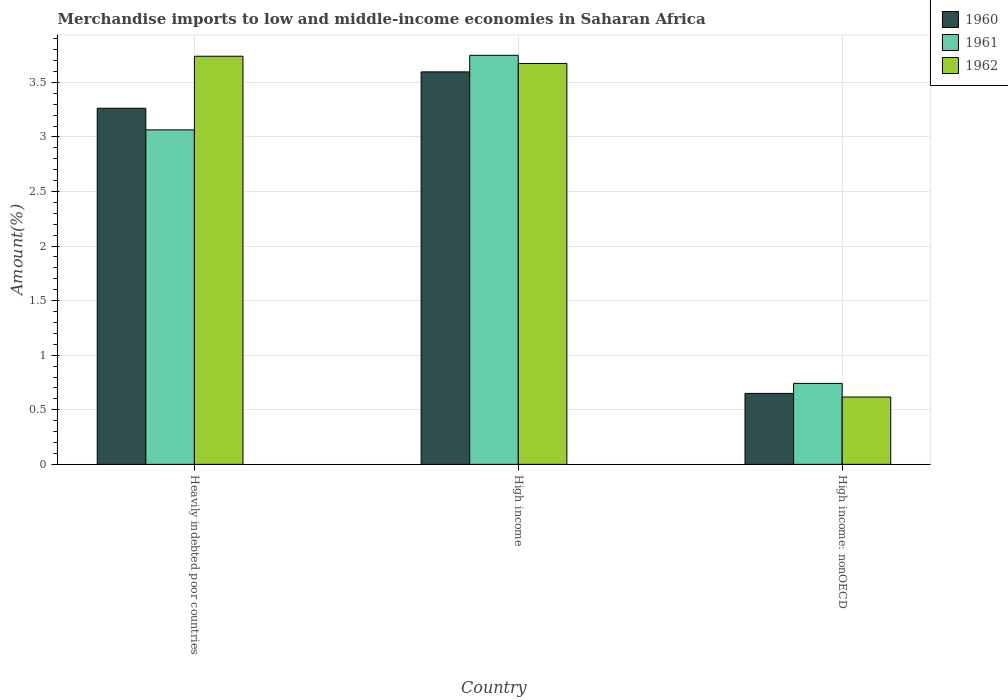How many different coloured bars are there?
Your response must be concise. 3. How many groups of bars are there?
Keep it short and to the point. 3. What is the percentage of amount earned from merchandise imports in 1962 in Heavily indebted poor countries?
Offer a very short reply. 3.74. Across all countries, what is the maximum percentage of amount earned from merchandise imports in 1962?
Keep it short and to the point. 3.74. Across all countries, what is the minimum percentage of amount earned from merchandise imports in 1962?
Offer a very short reply. 0.62. In which country was the percentage of amount earned from merchandise imports in 1962 minimum?
Offer a terse response. High income: nonOECD. What is the total percentage of amount earned from merchandise imports in 1961 in the graph?
Give a very brief answer. 7.55. What is the difference between the percentage of amount earned from merchandise imports in 1962 in High income and that in High income: nonOECD?
Your answer should be compact. 3.06. What is the difference between the percentage of amount earned from merchandise imports in 1962 in High income and the percentage of amount earned from merchandise imports in 1960 in High income: nonOECD?
Your answer should be compact. 3.02. What is the average percentage of amount earned from merchandise imports in 1960 per country?
Your response must be concise. 2.5. What is the difference between the percentage of amount earned from merchandise imports of/in 1961 and percentage of amount earned from merchandise imports of/in 1962 in High income: nonOECD?
Keep it short and to the point. 0.12. In how many countries, is the percentage of amount earned from merchandise imports in 1960 greater than 0.2 %?
Make the answer very short. 3. What is the ratio of the percentage of amount earned from merchandise imports in 1961 in Heavily indebted poor countries to that in High income: nonOECD?
Offer a very short reply. 4.13. Is the percentage of amount earned from merchandise imports in 1961 in High income less than that in High income: nonOECD?
Provide a short and direct response. No. Is the difference between the percentage of amount earned from merchandise imports in 1961 in Heavily indebted poor countries and High income: nonOECD greater than the difference between the percentage of amount earned from merchandise imports in 1962 in Heavily indebted poor countries and High income: nonOECD?
Keep it short and to the point. No. What is the difference between the highest and the second highest percentage of amount earned from merchandise imports in 1962?
Ensure brevity in your answer.  3.06. What is the difference between the highest and the lowest percentage of amount earned from merchandise imports in 1962?
Your answer should be compact. 3.12. Is it the case that in every country, the sum of the percentage of amount earned from merchandise imports in 1962 and percentage of amount earned from merchandise imports in 1960 is greater than the percentage of amount earned from merchandise imports in 1961?
Ensure brevity in your answer.  Yes. How many countries are there in the graph?
Provide a short and direct response. 3. Are the values on the major ticks of Y-axis written in scientific E-notation?
Your answer should be very brief. No. Does the graph contain any zero values?
Your answer should be very brief. No. Does the graph contain grids?
Your answer should be compact. Yes. How many legend labels are there?
Ensure brevity in your answer.  3. How are the legend labels stacked?
Provide a succinct answer. Vertical. What is the title of the graph?
Make the answer very short. Merchandise imports to low and middle-income economies in Saharan Africa. Does "1999" appear as one of the legend labels in the graph?
Ensure brevity in your answer.  No. What is the label or title of the X-axis?
Offer a terse response. Country. What is the label or title of the Y-axis?
Provide a succinct answer. Amount(%). What is the Amount(%) in 1960 in Heavily indebted poor countries?
Offer a very short reply. 3.26. What is the Amount(%) of 1961 in Heavily indebted poor countries?
Ensure brevity in your answer.  3.06. What is the Amount(%) in 1962 in Heavily indebted poor countries?
Keep it short and to the point. 3.74. What is the Amount(%) of 1960 in High income?
Your response must be concise. 3.6. What is the Amount(%) in 1961 in High income?
Provide a succinct answer. 3.75. What is the Amount(%) in 1962 in High income?
Keep it short and to the point. 3.67. What is the Amount(%) in 1960 in High income: nonOECD?
Make the answer very short. 0.65. What is the Amount(%) of 1961 in High income: nonOECD?
Your answer should be compact. 0.74. What is the Amount(%) of 1962 in High income: nonOECD?
Offer a very short reply. 0.62. Across all countries, what is the maximum Amount(%) of 1960?
Provide a short and direct response. 3.6. Across all countries, what is the maximum Amount(%) in 1961?
Give a very brief answer. 3.75. Across all countries, what is the maximum Amount(%) in 1962?
Offer a very short reply. 3.74. Across all countries, what is the minimum Amount(%) of 1960?
Make the answer very short. 0.65. Across all countries, what is the minimum Amount(%) in 1961?
Ensure brevity in your answer.  0.74. Across all countries, what is the minimum Amount(%) of 1962?
Keep it short and to the point. 0.62. What is the total Amount(%) in 1960 in the graph?
Ensure brevity in your answer.  7.51. What is the total Amount(%) of 1961 in the graph?
Ensure brevity in your answer.  7.55. What is the total Amount(%) of 1962 in the graph?
Offer a terse response. 8.03. What is the difference between the Amount(%) in 1960 in Heavily indebted poor countries and that in High income?
Your answer should be very brief. -0.33. What is the difference between the Amount(%) of 1961 in Heavily indebted poor countries and that in High income?
Offer a very short reply. -0.68. What is the difference between the Amount(%) in 1962 in Heavily indebted poor countries and that in High income?
Provide a short and direct response. 0.07. What is the difference between the Amount(%) of 1960 in Heavily indebted poor countries and that in High income: nonOECD?
Keep it short and to the point. 2.61. What is the difference between the Amount(%) in 1961 in Heavily indebted poor countries and that in High income: nonOECD?
Your response must be concise. 2.32. What is the difference between the Amount(%) in 1962 in Heavily indebted poor countries and that in High income: nonOECD?
Ensure brevity in your answer.  3.12. What is the difference between the Amount(%) of 1960 in High income and that in High income: nonOECD?
Your answer should be very brief. 2.95. What is the difference between the Amount(%) of 1961 in High income and that in High income: nonOECD?
Provide a succinct answer. 3.01. What is the difference between the Amount(%) of 1962 in High income and that in High income: nonOECD?
Your answer should be very brief. 3.06. What is the difference between the Amount(%) of 1960 in Heavily indebted poor countries and the Amount(%) of 1961 in High income?
Your response must be concise. -0.49. What is the difference between the Amount(%) in 1960 in Heavily indebted poor countries and the Amount(%) in 1962 in High income?
Provide a short and direct response. -0.41. What is the difference between the Amount(%) of 1961 in Heavily indebted poor countries and the Amount(%) of 1962 in High income?
Offer a terse response. -0.61. What is the difference between the Amount(%) of 1960 in Heavily indebted poor countries and the Amount(%) of 1961 in High income: nonOECD?
Give a very brief answer. 2.52. What is the difference between the Amount(%) of 1960 in Heavily indebted poor countries and the Amount(%) of 1962 in High income: nonOECD?
Provide a succinct answer. 2.65. What is the difference between the Amount(%) of 1961 in Heavily indebted poor countries and the Amount(%) of 1962 in High income: nonOECD?
Your answer should be compact. 2.45. What is the difference between the Amount(%) in 1960 in High income and the Amount(%) in 1961 in High income: nonOECD?
Your answer should be very brief. 2.85. What is the difference between the Amount(%) of 1960 in High income and the Amount(%) of 1962 in High income: nonOECD?
Your response must be concise. 2.98. What is the difference between the Amount(%) of 1961 in High income and the Amount(%) of 1962 in High income: nonOECD?
Your answer should be compact. 3.13. What is the average Amount(%) in 1960 per country?
Offer a terse response. 2.5. What is the average Amount(%) of 1961 per country?
Keep it short and to the point. 2.52. What is the average Amount(%) in 1962 per country?
Offer a very short reply. 2.68. What is the difference between the Amount(%) in 1960 and Amount(%) in 1961 in Heavily indebted poor countries?
Provide a short and direct response. 0.2. What is the difference between the Amount(%) in 1960 and Amount(%) in 1962 in Heavily indebted poor countries?
Make the answer very short. -0.48. What is the difference between the Amount(%) of 1961 and Amount(%) of 1962 in Heavily indebted poor countries?
Ensure brevity in your answer.  -0.67. What is the difference between the Amount(%) in 1960 and Amount(%) in 1961 in High income?
Make the answer very short. -0.15. What is the difference between the Amount(%) in 1960 and Amount(%) in 1962 in High income?
Ensure brevity in your answer.  -0.08. What is the difference between the Amount(%) in 1961 and Amount(%) in 1962 in High income?
Give a very brief answer. 0.07. What is the difference between the Amount(%) of 1960 and Amount(%) of 1961 in High income: nonOECD?
Provide a short and direct response. -0.09. What is the difference between the Amount(%) of 1960 and Amount(%) of 1962 in High income: nonOECD?
Offer a very short reply. 0.03. What is the difference between the Amount(%) of 1961 and Amount(%) of 1962 in High income: nonOECD?
Ensure brevity in your answer.  0.12. What is the ratio of the Amount(%) in 1960 in Heavily indebted poor countries to that in High income?
Your response must be concise. 0.91. What is the ratio of the Amount(%) in 1961 in Heavily indebted poor countries to that in High income?
Offer a terse response. 0.82. What is the ratio of the Amount(%) of 1962 in Heavily indebted poor countries to that in High income?
Provide a succinct answer. 1.02. What is the ratio of the Amount(%) in 1960 in Heavily indebted poor countries to that in High income: nonOECD?
Your response must be concise. 5.02. What is the ratio of the Amount(%) in 1961 in Heavily indebted poor countries to that in High income: nonOECD?
Offer a very short reply. 4.13. What is the ratio of the Amount(%) of 1962 in Heavily indebted poor countries to that in High income: nonOECD?
Provide a short and direct response. 6.06. What is the ratio of the Amount(%) of 1960 in High income to that in High income: nonOECD?
Your answer should be compact. 5.53. What is the ratio of the Amount(%) of 1961 in High income to that in High income: nonOECD?
Your response must be concise. 5.05. What is the ratio of the Amount(%) of 1962 in High income to that in High income: nonOECD?
Your answer should be compact. 5.95. What is the difference between the highest and the second highest Amount(%) of 1960?
Make the answer very short. 0.33. What is the difference between the highest and the second highest Amount(%) in 1961?
Offer a very short reply. 0.68. What is the difference between the highest and the second highest Amount(%) of 1962?
Your response must be concise. 0.07. What is the difference between the highest and the lowest Amount(%) in 1960?
Make the answer very short. 2.95. What is the difference between the highest and the lowest Amount(%) of 1961?
Your response must be concise. 3.01. What is the difference between the highest and the lowest Amount(%) in 1962?
Your answer should be compact. 3.12. 